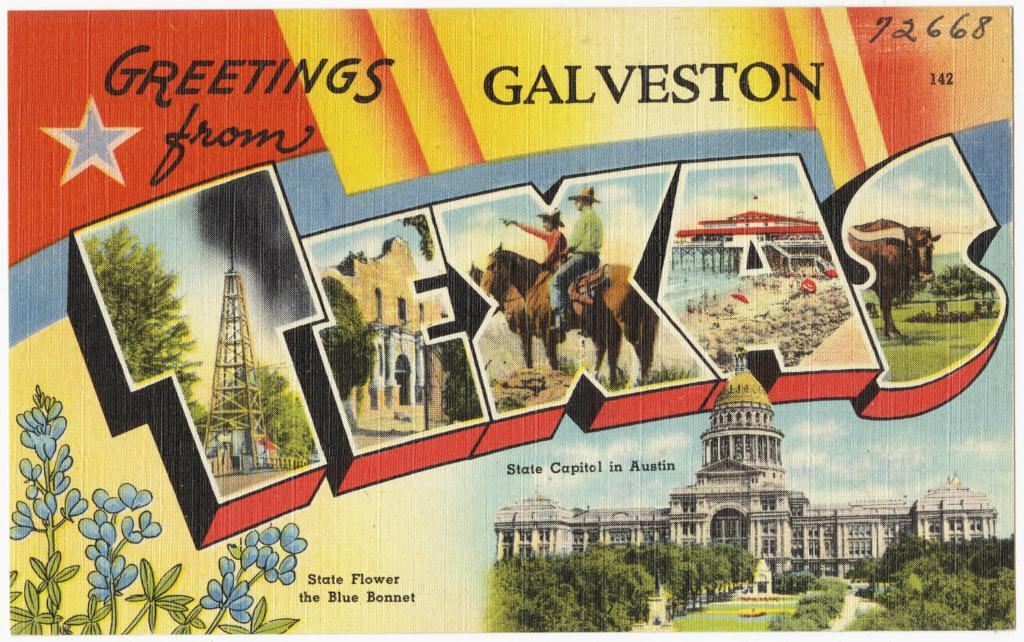Provide a one-sentence caption for the provided image. A colorful postcard that reads "Greetings from Galveston Texas.". 